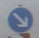In this task, you will classify traffic signs in the given image. The image is in color and contains various traffic signs captured in real-world conditions. Your goal is to accurately identify the type of traffic sign present in the image. Consider factors such as the sign's shape, color, and symbols to ensure correct classification. A sample output should look like this: 'Speed limit (80km/h)'
Options: (a) Speed limit (20km/h) (b) End of speed limit (80km/h) (c) Road narrows on the right (d) No entry (e) Priority road (f) Keep right (g) Go straight or left (h) Dangerous curve to the left (i) Roundabout mandatory (j) End of no passing Given the provided image, the signs in view struggle with clarity, making detailed classification difficult. To handle such cases, it would be helpful to use image enhancement tools to sharpen and adjust the image's contrast for clarity. In general, signs that are unclear should be analyzed with enhanced software tools or physically revisited for direct observation, if possible. Tips for recognizing common signs like 'Speed limits' often involve looking for circular shapes and red or blue backgrounds. Without clearer imagery, classifying from these options remains speculative, and adequate visualization is recommended. 